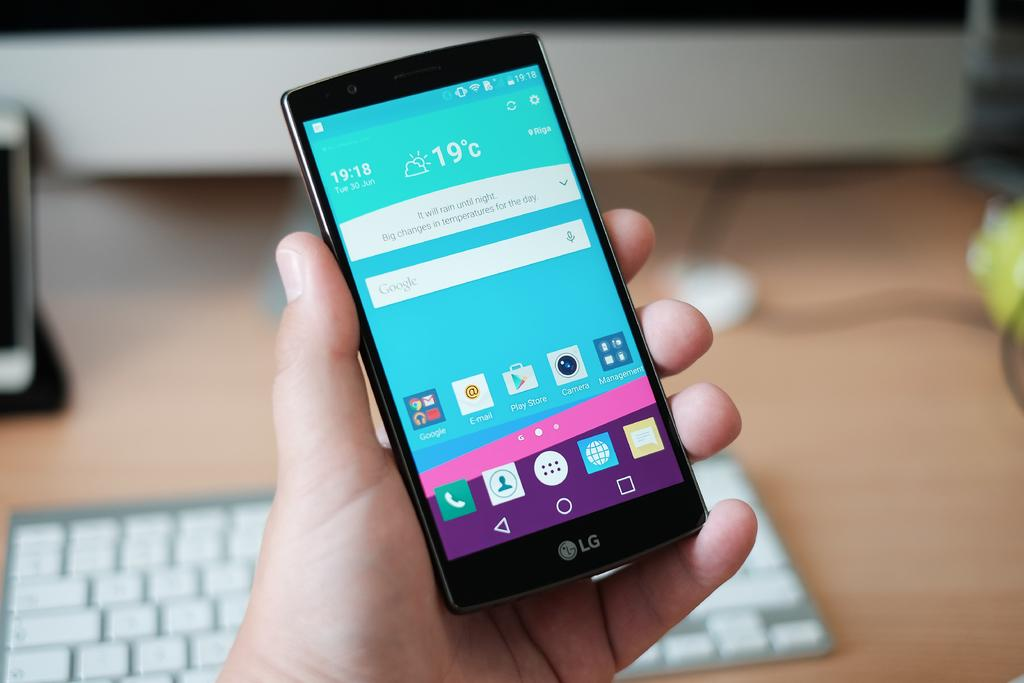<image>
Summarize the visual content of the image. A person holding a phone in his hand with the time 19:18 displayed. 